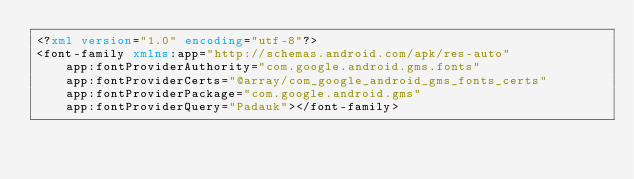<code> <loc_0><loc_0><loc_500><loc_500><_XML_><?xml version="1.0" encoding="utf-8"?>
<font-family xmlns:app="http://schemas.android.com/apk/res-auto"
    app:fontProviderAuthority="com.google.android.gms.fonts"
    app:fontProviderCerts="@array/com_google_android_gms_fonts_certs"
    app:fontProviderPackage="com.google.android.gms"
    app:fontProviderQuery="Padauk"></font-family>
</code> 